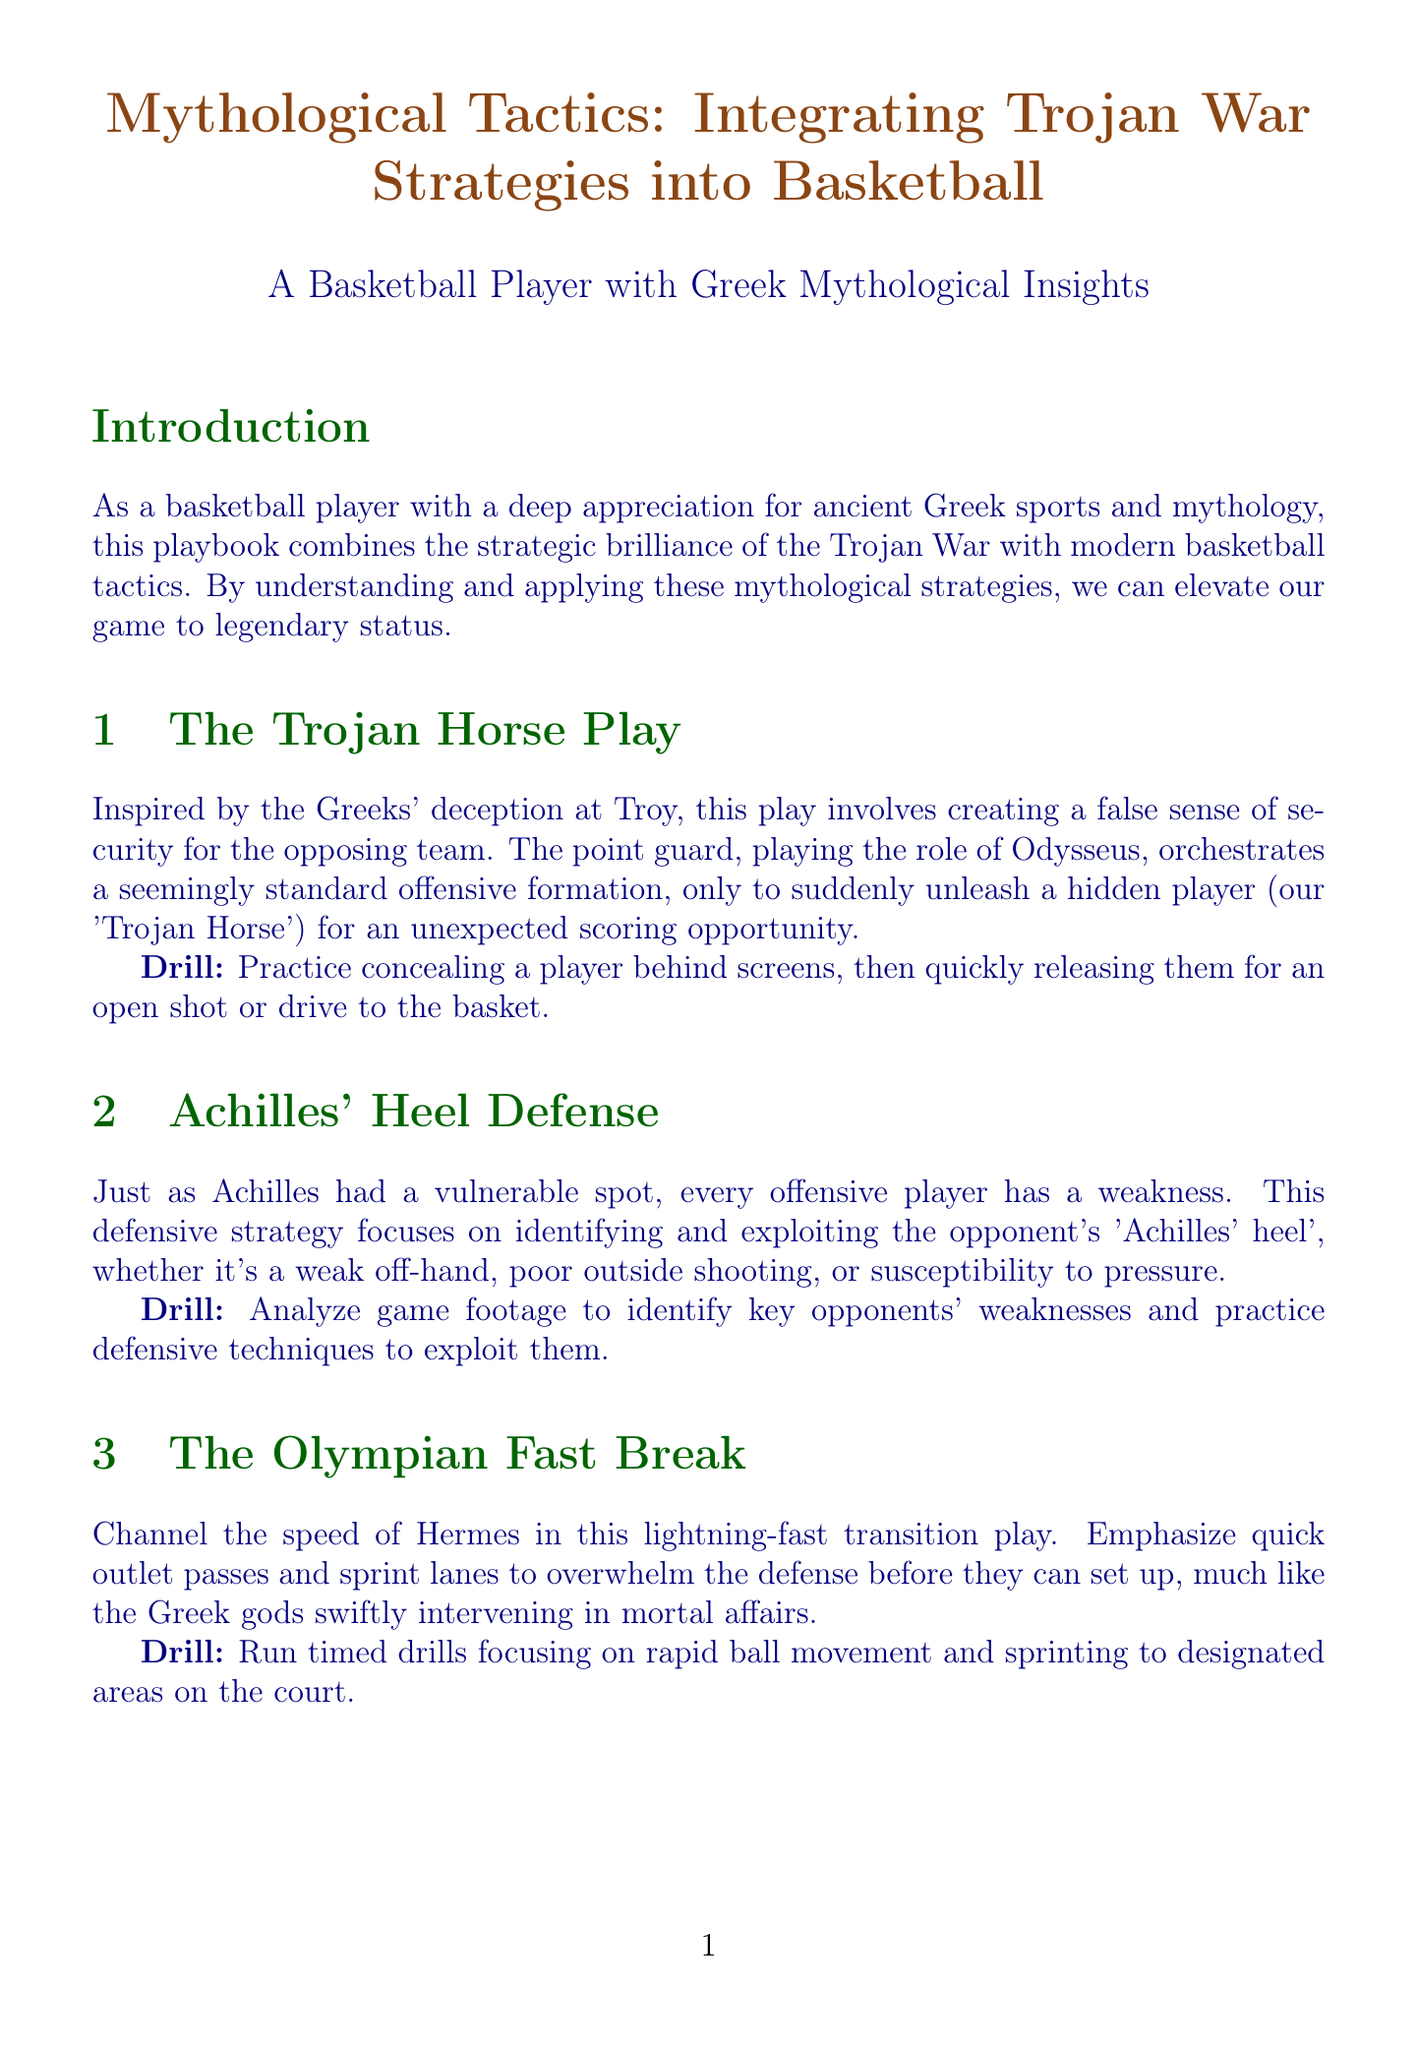What is the title of the playbook? The title is found at the top of the document.
Answer: Mythological Tactics: Integrating Trojan War Strategies into Basketball Who is compared to Odysseus in the Trojan Horse Play? The playbook identifies the position that takes on Odysseus's role.
Answer: Point guard What type of defense is Achilles' Heel Defense? The document classifies the defensive strategy mentioned.
Answer: Defensive strategy What does the Olympian Fast Break emphasize? This play involves specific techniques that are highlighted in the content.
Answer: Quick outlet passes What is Poseidon's Trident Offense comprised of? The playbook outlines the structure of this offensive strategy.
Answer: Strong post presence and two sharp-shooting wings How many drills are listed for the Golden Fleece Pick-and-Roll? The number of drills related to this strategy is detailed in the document.
Answer: One What is the suggested reading about Greek mythology? The appendix provides books related to Greek mythology.
Answer: Greek Mythology: A Concise Guide to Ancient Gods, Heroes, Beliefs and Myths of Greek Mythology by Robert Graves Who is referred to as the GOAT in the historical basketball figures? This figure is noted for their exceptional status in basketball.
Answer: Michael Jordan What is the final section of the document called? The document structure leads to a summarized section at the end.
Answer: Conclusion 